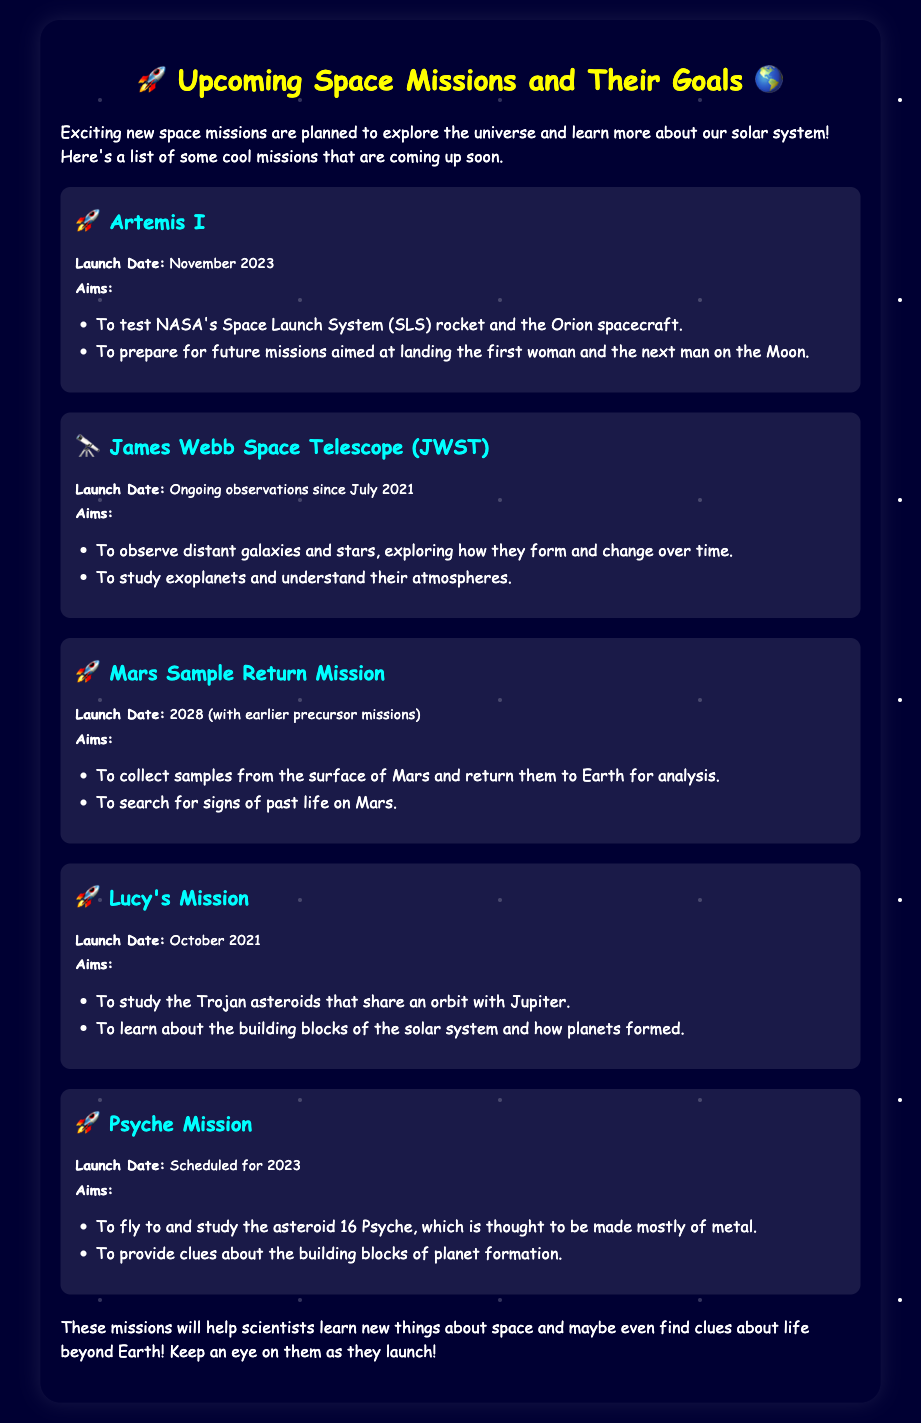What is the launch date of Artemis I? The launch date of Artemis I is specified in the document.
Answer: November 2023 What is the aim of the James Webb Space Telescope? The aim is described as observing distant galaxies and stars.
Answer: To observe distant galaxies and stars When is the Mars Sample Return Mission scheduled to launch? The launch date for this mission is given in the document.
Answer: 2028 What is the main goal of Lucy's Mission? The document states that this mission aims to study Trojan asteroids.
Answer: To study the Trojan asteroids What does the Psyche Mission aim to study? The document mentions that the Psyche Mission will study an asteroid thought to be mostly made of metal.
Answer: The asteroid 16 Psyche What is a common goal of all mentioned missions? The question looks for an overarching theme in the document.
Answer: To learn about space How long has the James Webb Space Telescope been observing? The document provides the start date of the observations for this telescope.
Answer: Since July 2021 What aims to collect samples from the surface of Mars? This refers to a specific mission detailed in the document.
Answer: Mars Sample Return Mission What color is used for the mission titles? This question tests knowledge of specific visual details in the document.
Answer: Cyan 